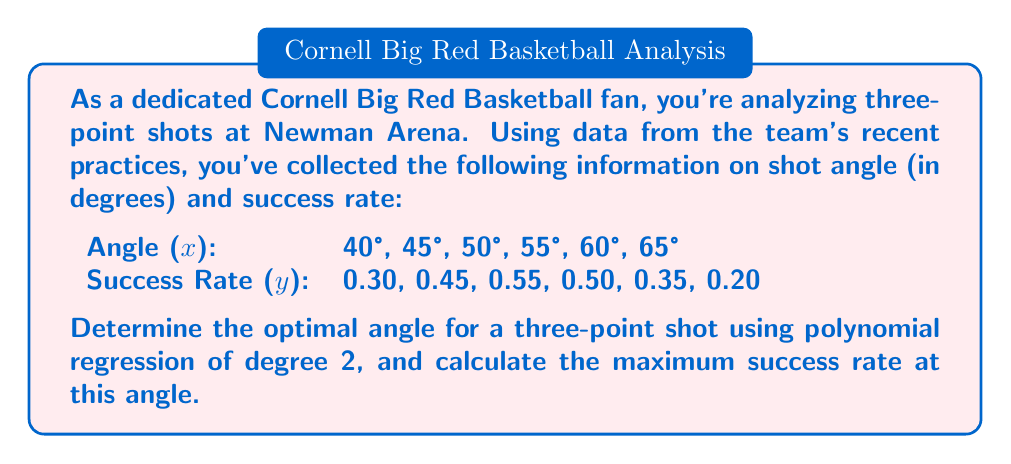Teach me how to tackle this problem. Let's approach this step-by-step:

1) For a polynomial regression of degree 2, we're looking for a function of the form:
   $$ y = ax^2 + bx + c $$

2) To find the coefficients a, b, and c, we'll use the normal equations for polynomial regression:
   $$ \begin{bmatrix} 
   \sum x^4 & \sum x^3 & \sum x^2 \\
   \sum x^3 & \sum x^2 & \sum x \\
   \sum x^2 & \sum x & n
   \end{bmatrix}
   \begin{bmatrix}
   a \\ b \\ c
   \end{bmatrix} =
   \begin{bmatrix}
   \sum x^2y \\ \sum xy \\ \sum y
   \end{bmatrix} $$

3) Calculating the sums:
   $\sum x^4 = 7,975,000$
   $\sum x^3 = 860,625$
   $\sum x^2 = 93,950$
   $\sum x = 315$
   $n = 6$
   $\sum x^2y = 4,913.75$
   $\sum xy = 143.75$
   $\sum y = 2.35$

4) Substituting into the matrix equation:
   $$ \begin{bmatrix} 
   7,975,000 & 860,625 & 93,950 \\
   860,625 & 93,950 & 315 \\
   93,950 & 315 & 6
   \end{bmatrix}
   \begin{bmatrix}
   a \\ b \\ c
   \end{bmatrix} =
   \begin{bmatrix}
   4,913.75 \\ 143.75 \\ 2.35
   \end{bmatrix} $$

5) Solving this system of equations (using a calculator or computer algebra system), we get:
   $a \approx -0.00189$, $b \approx 0.1884$, $c \approx -4.2075$

6) Therefore, our regression equation is:
   $$ y \approx -0.00189x^2 + 0.1884x - 4.2075 $$

7) To find the maximum of this parabola, we differentiate and set to zero:
   $$ \frac{dy}{dx} = -0.00378x + 0.1884 = 0 $$

8) Solving for x:
   $$ x = \frac{0.1884}{0.00378} \approx 49.84 $$

9) The optimal angle is approximately 49.84°.

10) To find the maximum success rate, we substitute this x-value back into our regression equation:
    $$ y \approx -0.00189(49.84)^2 + 0.1884(49.84) - 4.2075 \approx 0.5505 $$

Therefore, the maximum success rate is approximately 0.5505 or 55.05%.
Answer: Optimal angle: 49.84°; Maximum success rate: 55.05% 